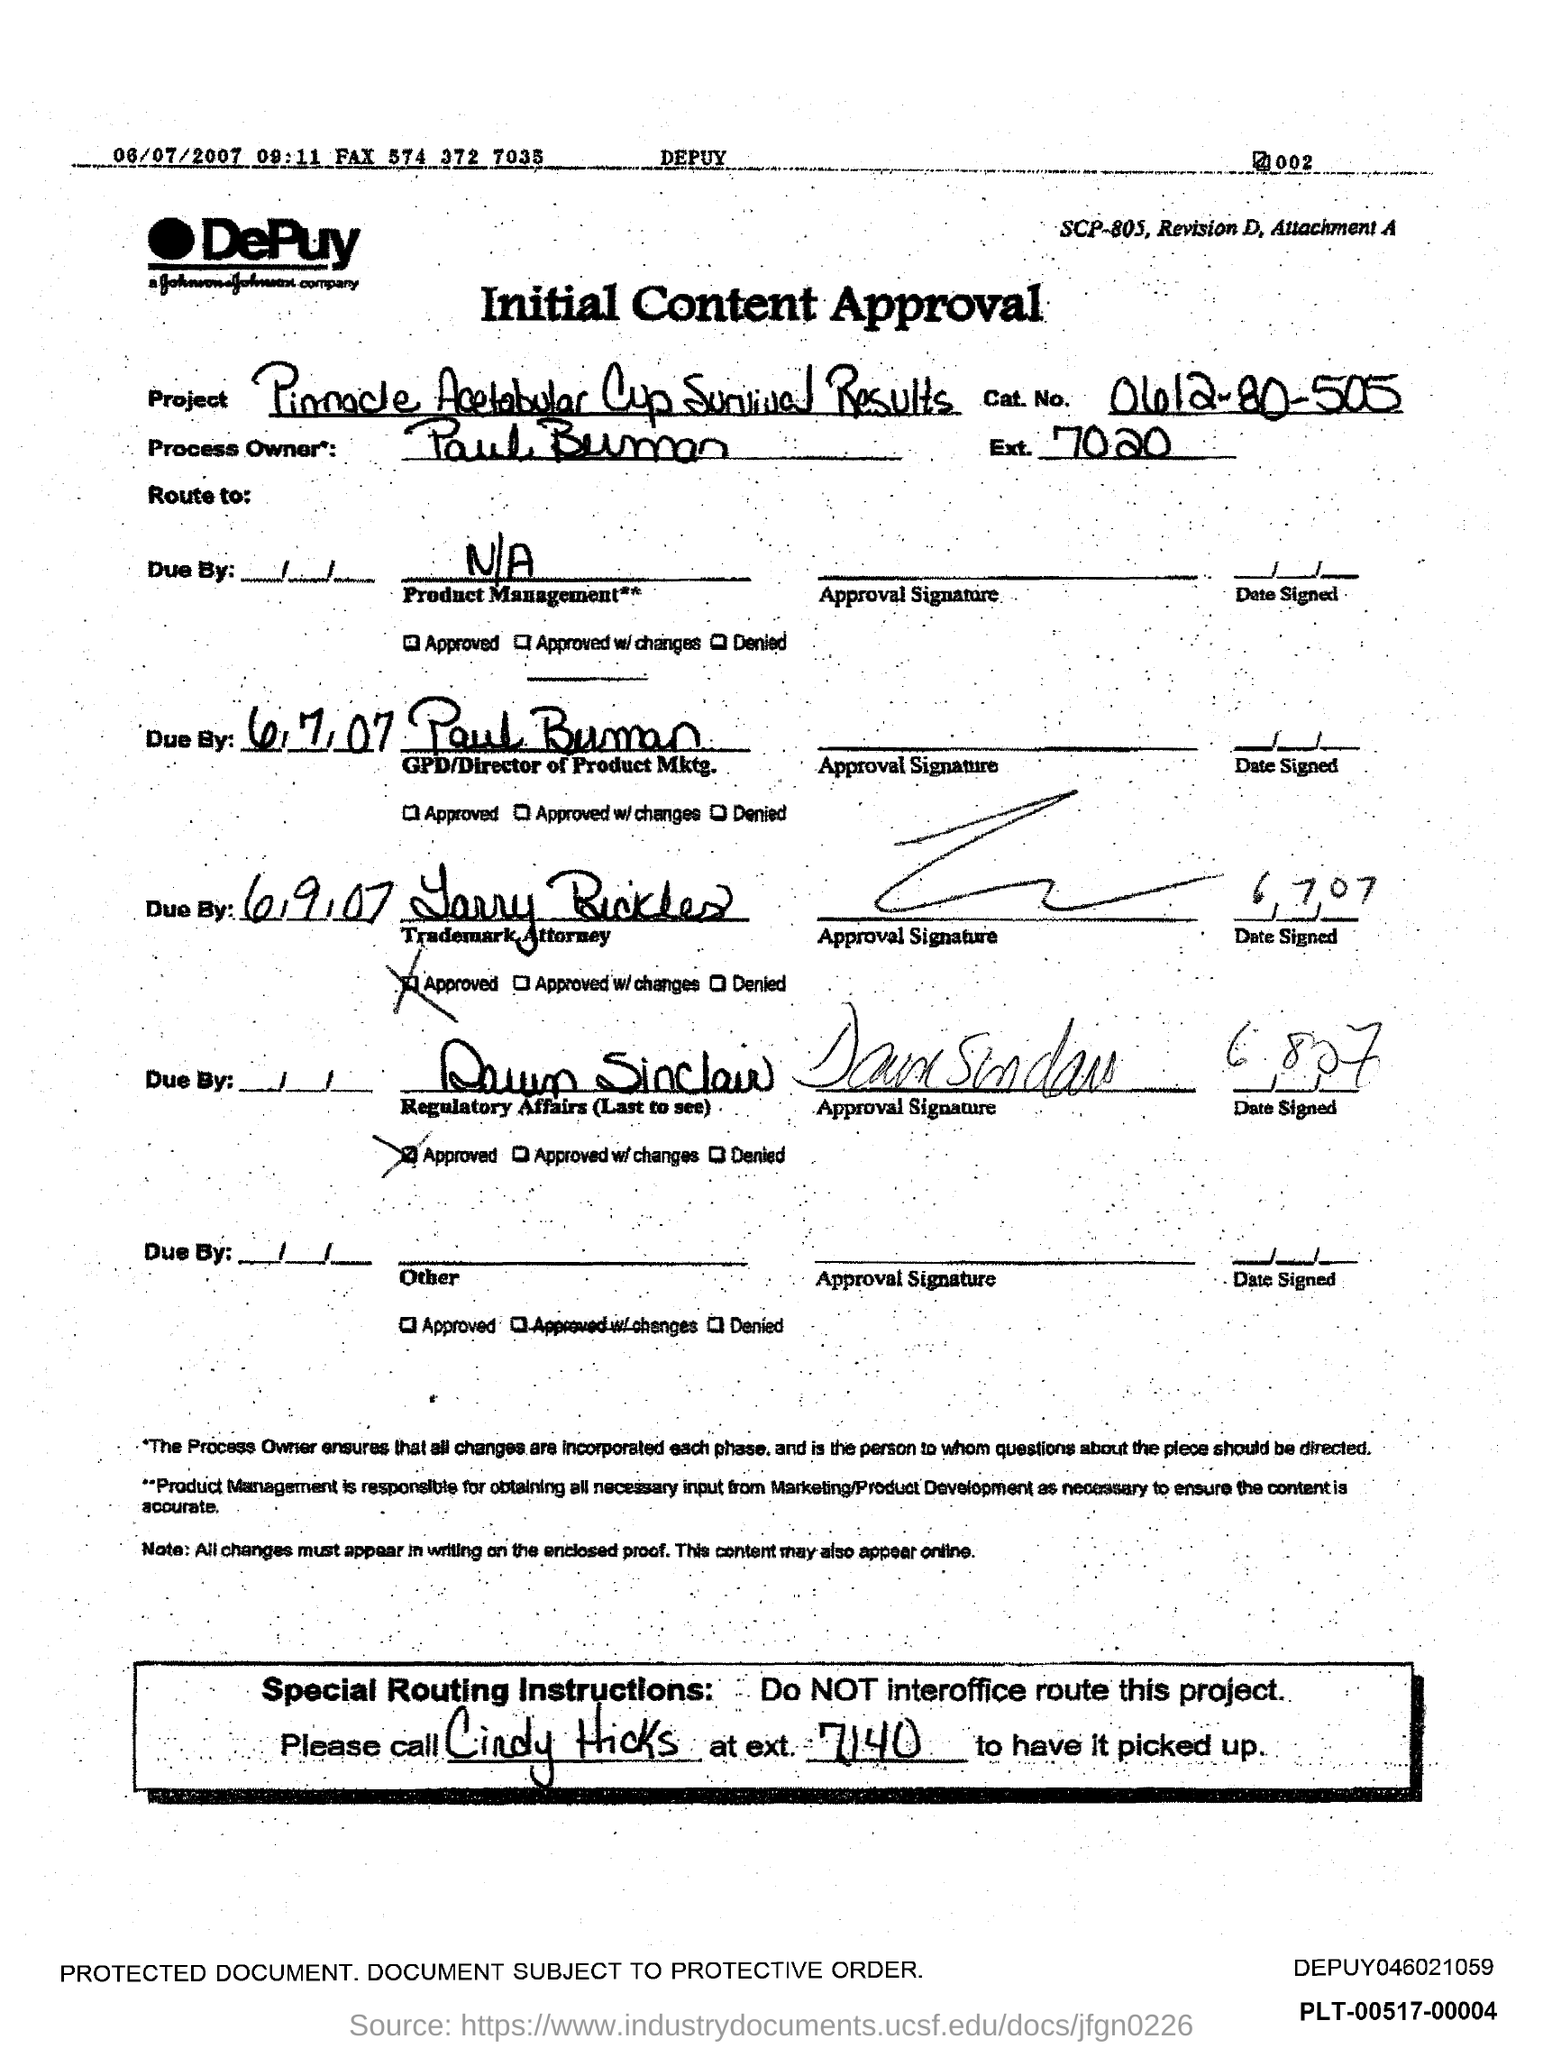What type of approval is this?
Provide a succinct answer. Initial Content Approval. Which project is mentioned in the approval?
Keep it short and to the point. Pinnacle Acetabular Cup Survival Results. What is the Cat. No. given in the approval?
Make the answer very short. 0612-80-505. Who is the process owner mentioned in the approval?
Keep it short and to the point. Paul Buman. What is the Ext. No. of Paul Buman?
Provide a short and direct response. 7020. 